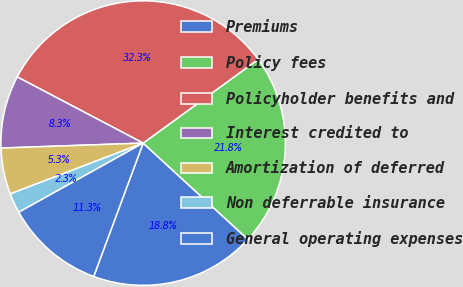Convert chart to OTSL. <chart><loc_0><loc_0><loc_500><loc_500><pie_chart><fcel>Premiums<fcel>Policy fees<fcel>Policyholder benefits and<fcel>Interest credited to<fcel>Amortization of deferred<fcel>Non deferrable insurance<fcel>General operating expenses<nl><fcel>18.83%<fcel>21.84%<fcel>32.29%<fcel>8.26%<fcel>5.26%<fcel>2.26%<fcel>11.27%<nl></chart> 